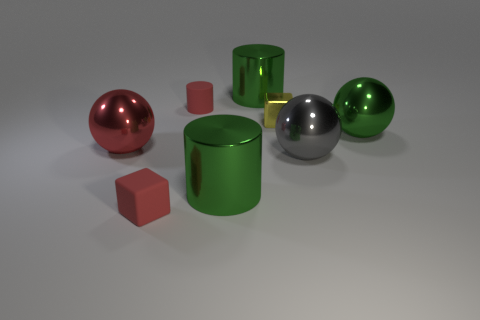Does the yellow object have the same material as the big gray ball?
Ensure brevity in your answer.  Yes. There is a red rubber thing in front of the tiny red cylinder; how many big metal objects are to the right of it?
Provide a succinct answer. 4. Does the block on the left side of the yellow metallic thing have the same color as the tiny cylinder?
Your answer should be very brief. Yes. What number of objects are either small green cubes or shiny objects that are on the right side of the matte block?
Keep it short and to the point. 5. Do the red matte object that is behind the green ball and the small red rubber object in front of the red ball have the same shape?
Provide a succinct answer. No. Is there any other thing of the same color as the matte cylinder?
Your answer should be compact. Yes. There is a small yellow thing that is made of the same material as the big red object; what shape is it?
Give a very brief answer. Cube. What material is the thing that is in front of the large red object and on the left side of the small red rubber cylinder?
Offer a terse response. Rubber. Is there any other thing that has the same size as the yellow metallic block?
Offer a very short reply. Yes. Is the color of the tiny rubber block the same as the rubber cylinder?
Offer a terse response. Yes. 